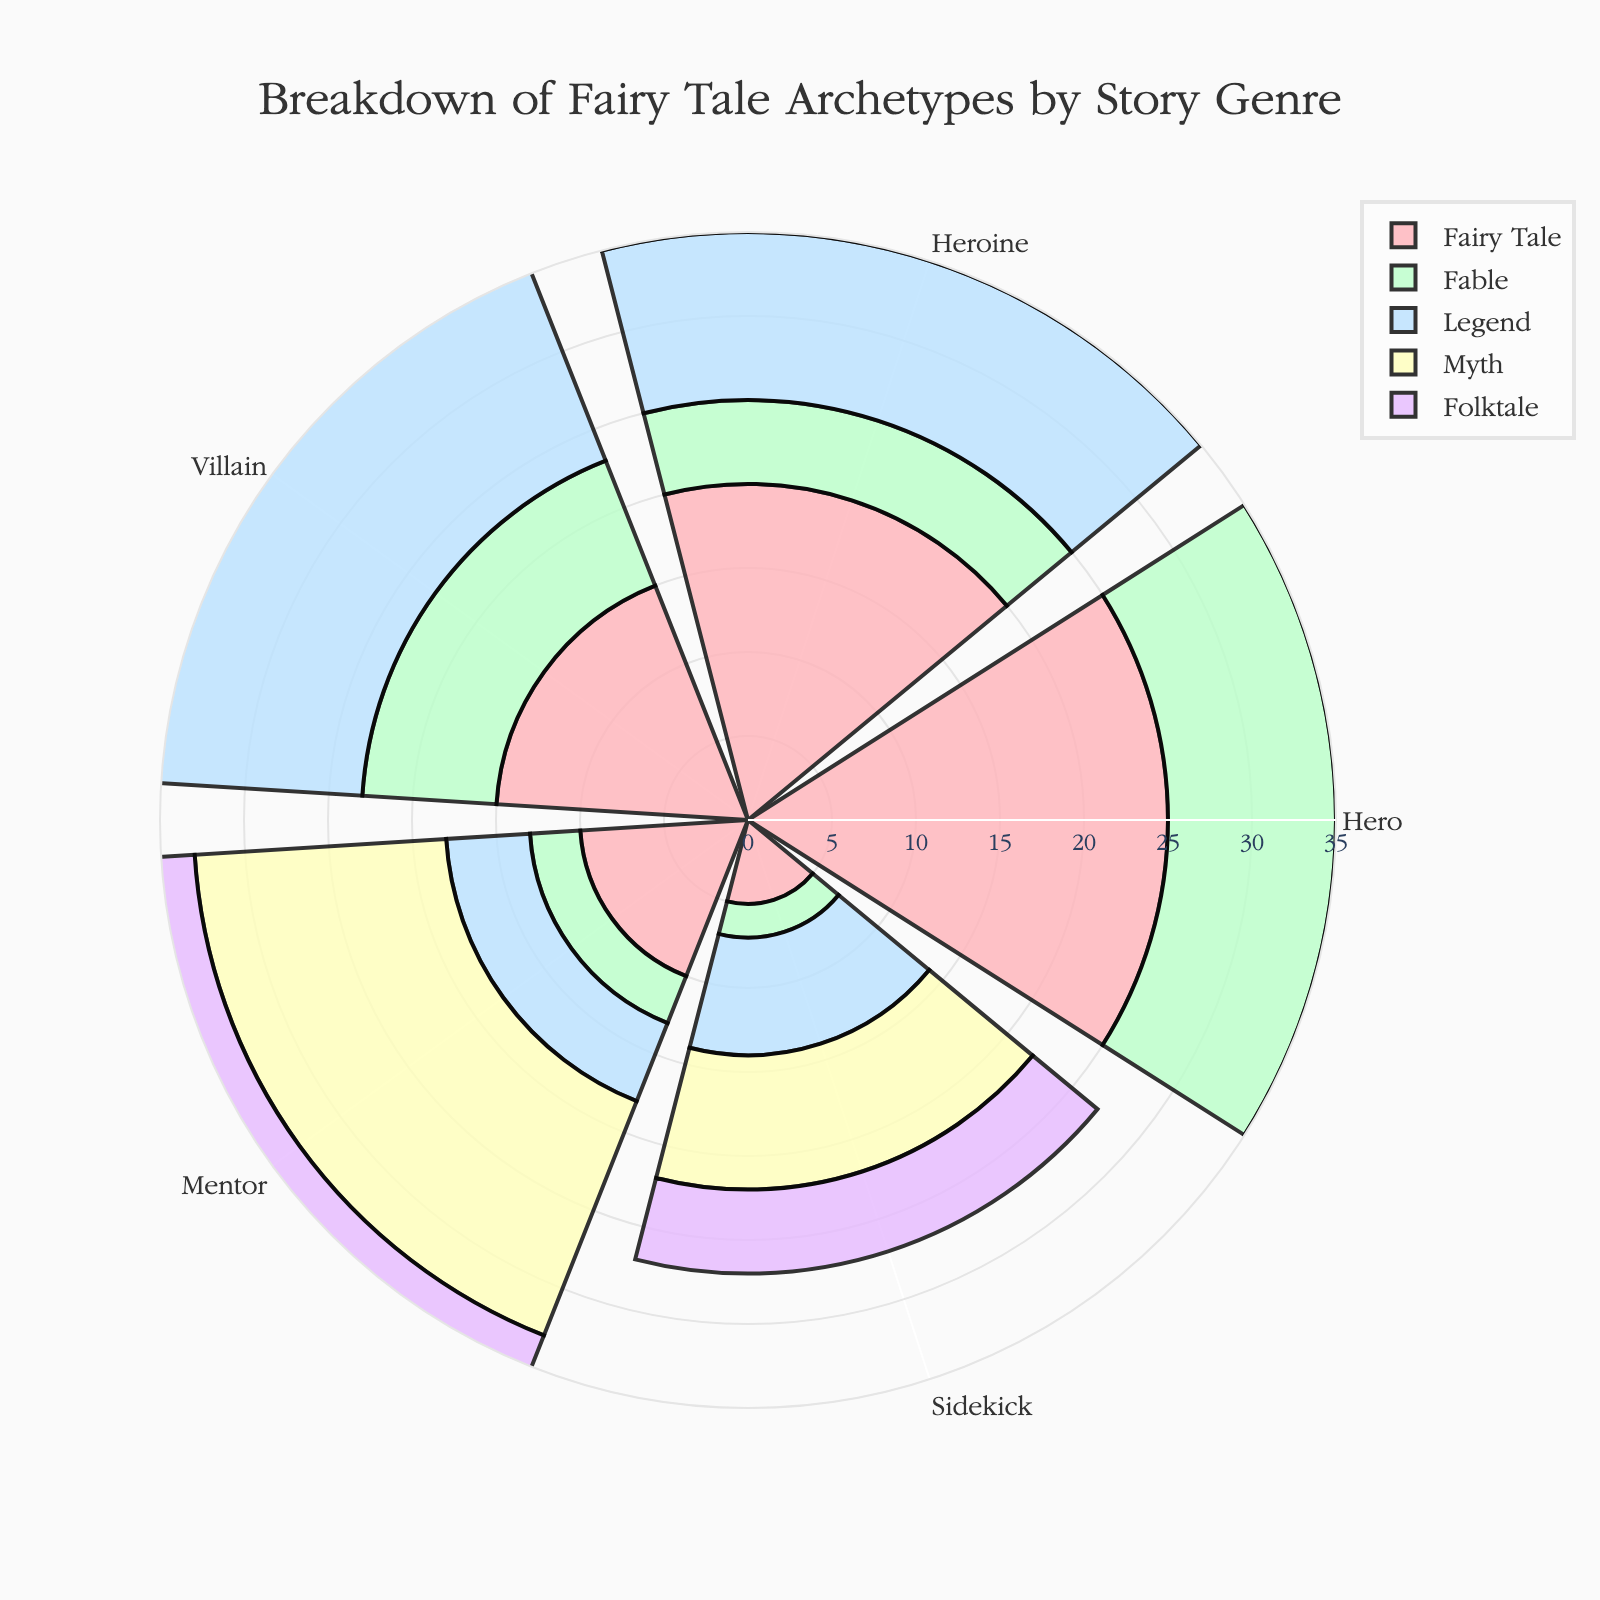Which genre has the most Heroes? Look at the category "Hero" across all the genres. The genre with the highest value for Heroes is "Legend" with 30 Heroes.
Answer: Legend Which genre has the least Sidekicks? Examine the "Sidekick" category across all genres. "Fable" has the least Sidekicks with a value of 2.
Answer: Fable How many total Mentors are there in all genres combined? Sum the number of Mentors across all genres: 10 (Fairy Tale) + 3 (Fable) + 5 (Legend) + 15 (Myth) + 5 (Folktale) = 38 Mentors.
Answer: 38 Is the number of Villains in "Fairy Tale" greater than in "Fable"? Compare the Villains count for the two genres: "Fairy Tale" has 15 Villains and "Fable" has 8 Villains. Yes, 15 > 8.
Answer: Yes Which genre has the greatest combined number of Heroes and Heroines? Add Heroes and Heroines for each genre: 
Fairy Tale: 25 + 20 = 45
Fable: 10 + 5 = 15
Legend: 30 + 10 = 40
Myth: 20 + 15 = 35
Folktale: 15 + 10 = 25
Fairy Tale has the greatest combined number with 45.
Answer: Fairy Tale Among the archetype categories, which one has the highest overall total across all genres? Sum each archetype across all genres and compare:
Heroes: 25+10+30+20+15 = 100
Heroines: 20+5+10+15+10 = 60
Villains: 15+8+15+10+10 = 58
Mentors: 10+3+5+15+5 = 38
Sidekicks: 5+2+7+8+5 = 27
Heroes have the highest total with 100.
Answer: Heroes Does "Myth" have more Mentors than Sidekicks? Compare the counts for "Myth": Mentors have 15 and Sidekicks have 8. Yes, 15 > 8.
Answer: Yes Which genre has the most evenly distributed archetype categories (i.e., smallest difference between its highest and lowest values)? Calculate the range (maximum - minimum) of each genre and find the smallest range:
Fairy Tale: 25-5 = 20
Fable: 10-2 = 8
Legend: 30-5 = 25
Myth: 20-8 = 7
Folktale: 15-5 = 10
"Myth" has the smallest range of 7, indicating the most evenly distributed archetypes.
Answer: Myth How do the numbers of Heroes and Villains in "Legend" compare? Look at the counts for "Legend": Heroes are 30 and Villains are 15. Thus, there are twice as many Heroes as Villains.
Answer: Heroes are twice Villains in Legend Which genre has the least Heroines, and what is the exact number? Compare the number of Heroines across all genres: "Fable" has the least with a count of 5.
Answer: Fable, 5 